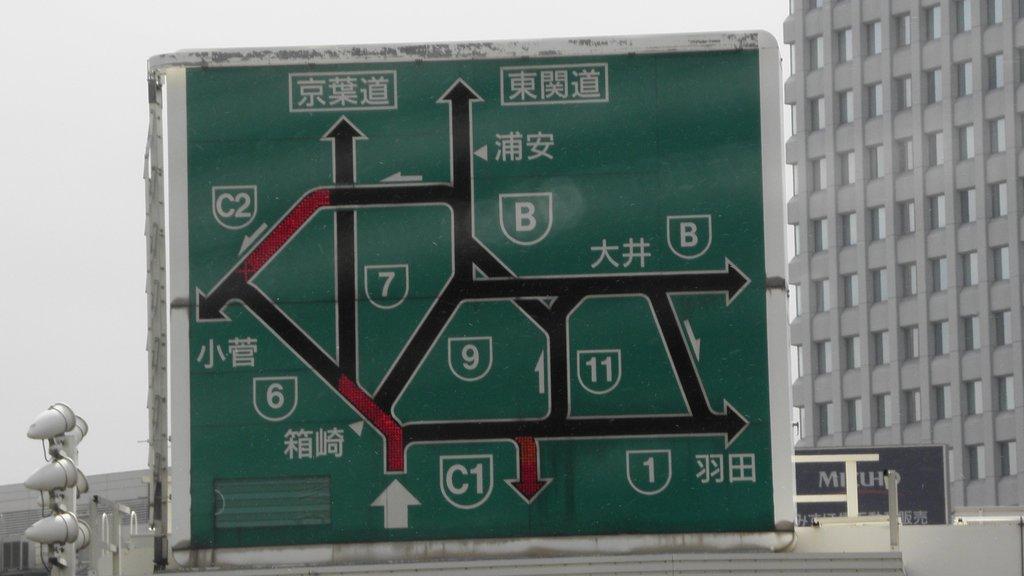What is shown next to the right of the arrow?
Give a very brief answer. C1. 